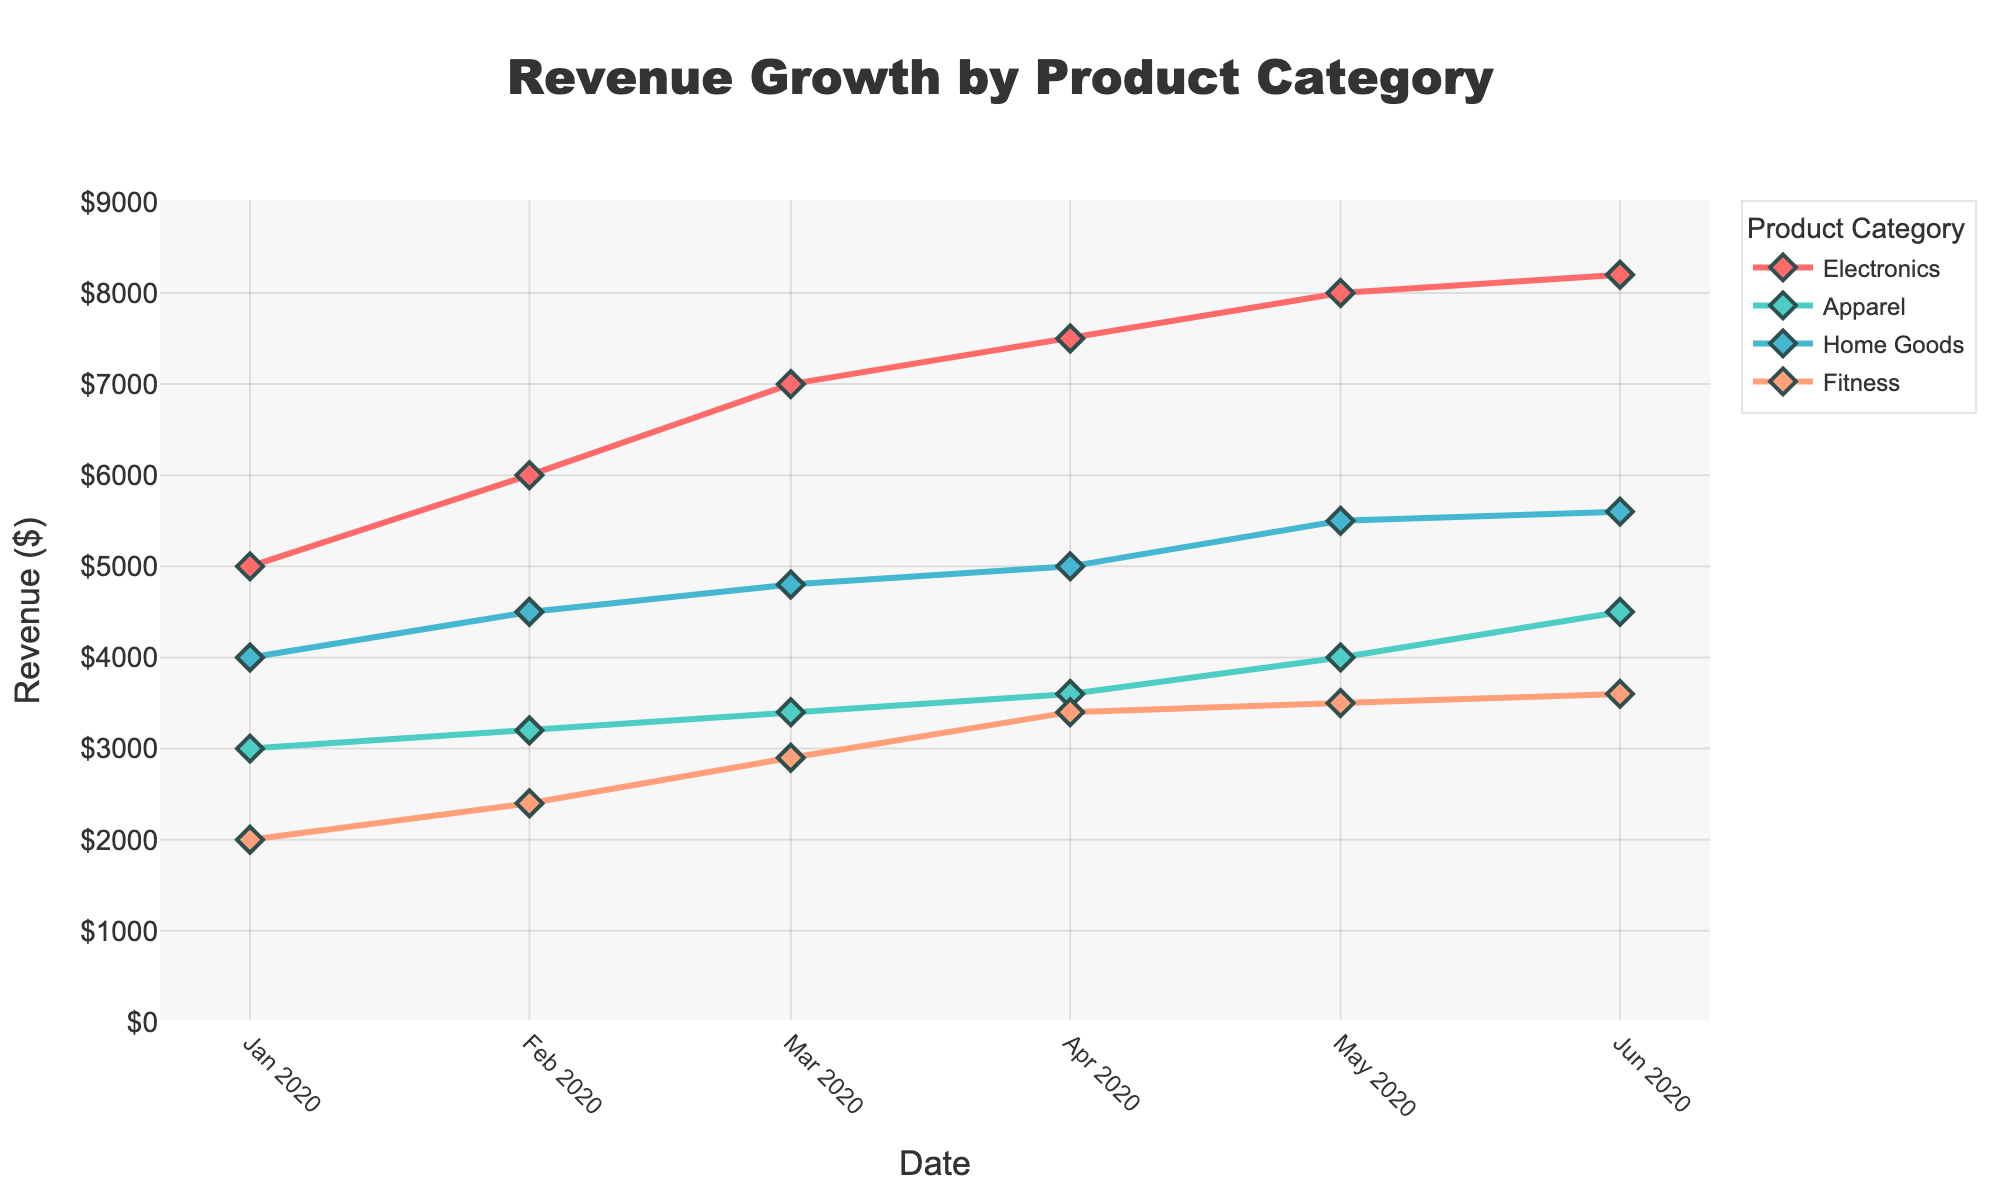How many product categories are represented in the figure? The figure shows lines for multiple product categories, each with a unique name in the legend. Count the number of unique names in the legend.
Answer: 4 Which product category has the highest revenue in June 2020? In June 2020, observe the highest point on the y-axis for each product category and compare their values.
Answer: Electronics What is the title of the figure? The title is displayed prominently at the top of the figure.
Answer: Revenue Growth by Product Category What is the total revenue for Apparel from January to June 2020? Sum up the revenue values for Apparel from January to June 2020 by adding each monthly value.
Answer: $21,700 By how much did the revenue for Fitness grow between January and April 2020? Subtract the Fitness revenue in January from the Fitness revenue in April to find the difference.
Answer: $1,400 Which month shows the highest revenue for Home Goods? Identify the month where the y-value for the Home Goods line is at its peak.
Answer: May 2020 What is the minimum revenue recorded in the figure, and for which category and month? Locate the lowest point in the entire plot, then identify the corresponding product category and month.
Answer: $2,000 for Fitness in January 2020 How does the revenue trend for Electronics compare to that of Fitness over the displayed period? Observe the slopes and trends of the lines for Electronics and Fitness to compare their revenue growth patterns over time.
Answer: Electronics consistently grows; Fitness has a sharp initial increase, then stabilizes During which months did Apparel experience noticeable revenue growth, and by how much? Examine the markers for Apparel to find the months with significant revenue increases, then calculate the difference between those months.
Answer: April to May, by $400 What is the average monthly revenue for Home Goods from January to June 2020? Calculate the average by summing the monthly revenues for Home Goods, then dividing by the number of months (6).
Answer: $4,800 